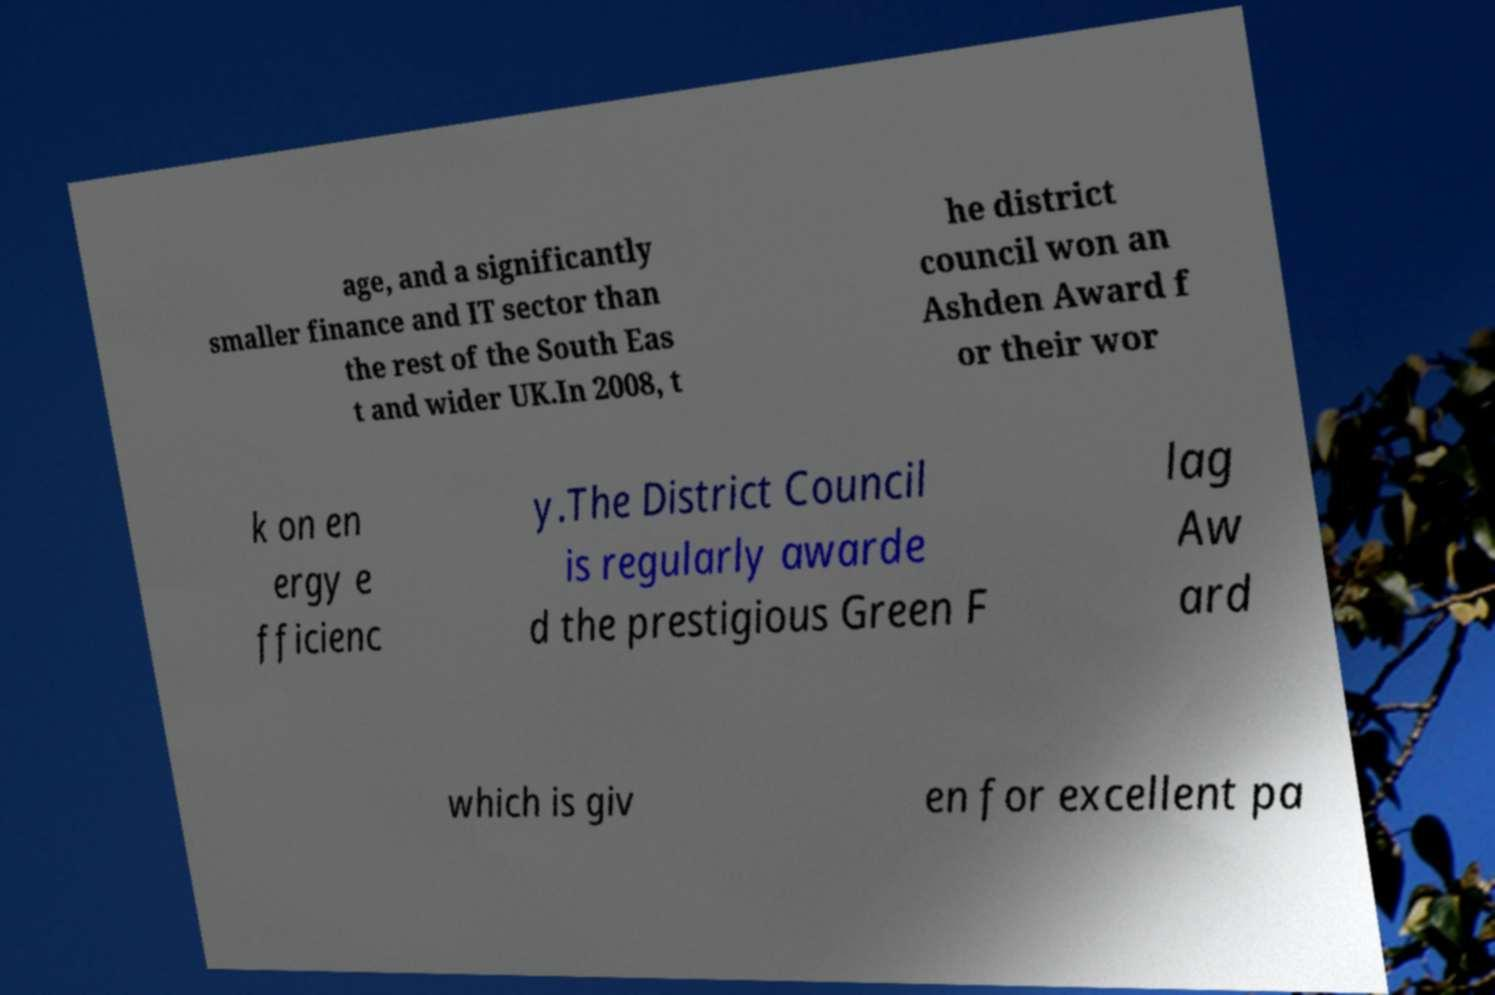I need the written content from this picture converted into text. Can you do that? age, and a significantly smaller finance and IT sector than the rest of the South Eas t and wider UK.In 2008, t he district council won an Ashden Award f or their wor k on en ergy e fficienc y.The District Council is regularly awarde d the prestigious Green F lag Aw ard which is giv en for excellent pa 